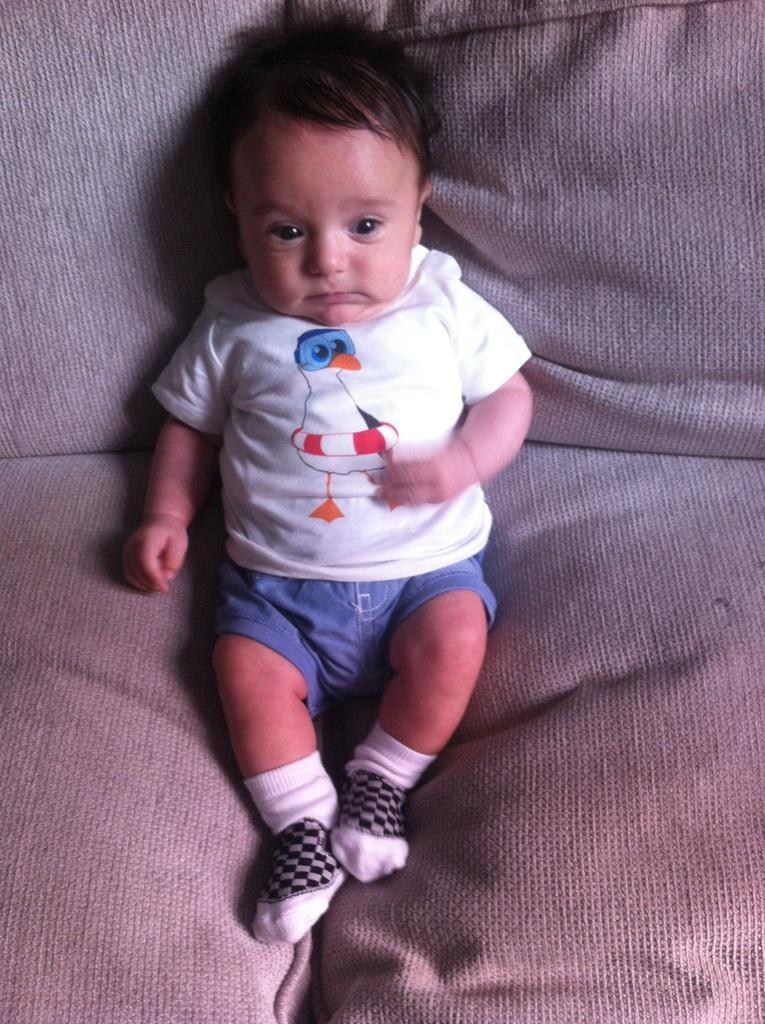What is the main subject of the image? The main subject of the image is a kid. Where is the kid located in the image? The kid is sitting on a couch. What type of rod is the kid using to stamp their birth certificate in the image? There is no rod or stamp present in the image, and no birth certificate is being processed. 